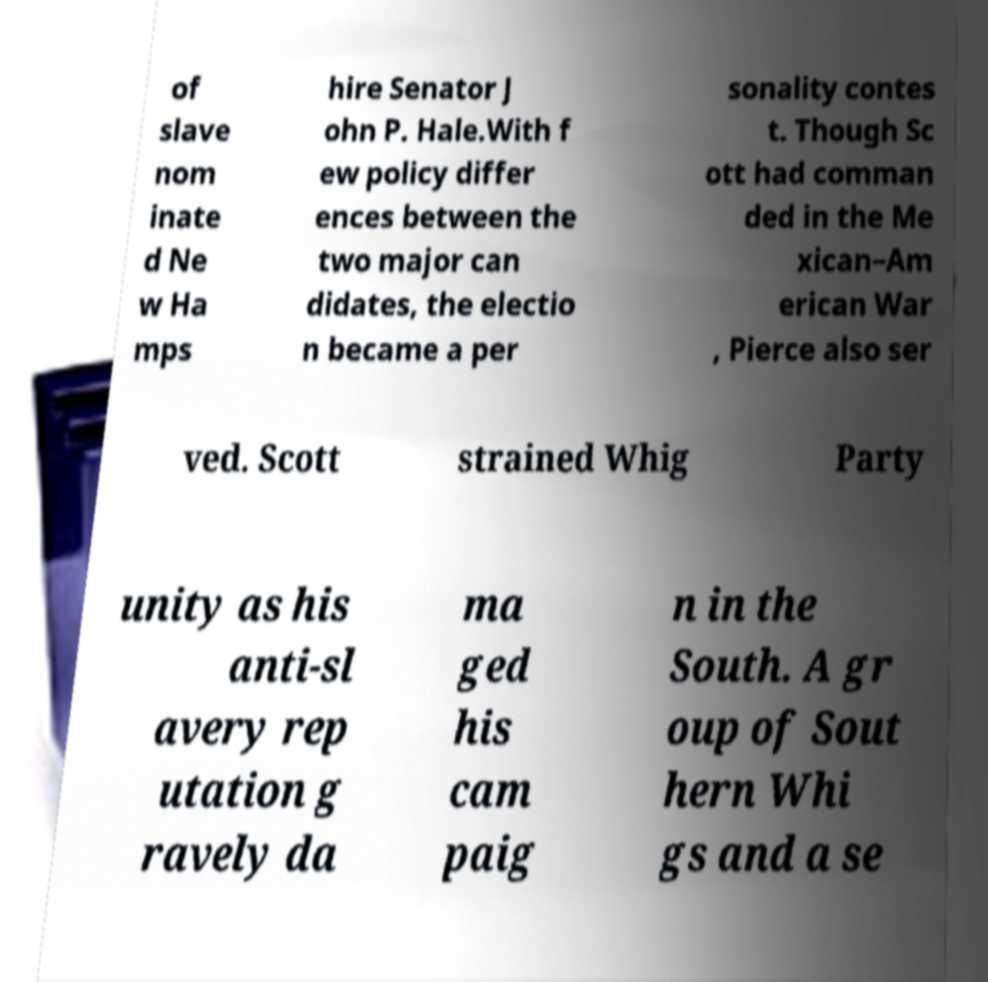Can you accurately transcribe the text from the provided image for me? of slave nom inate d Ne w Ha mps hire Senator J ohn P. Hale.With f ew policy differ ences between the two major can didates, the electio n became a per sonality contes t. Though Sc ott had comman ded in the Me xican–Am erican War , Pierce also ser ved. Scott strained Whig Party unity as his anti-sl avery rep utation g ravely da ma ged his cam paig n in the South. A gr oup of Sout hern Whi gs and a se 